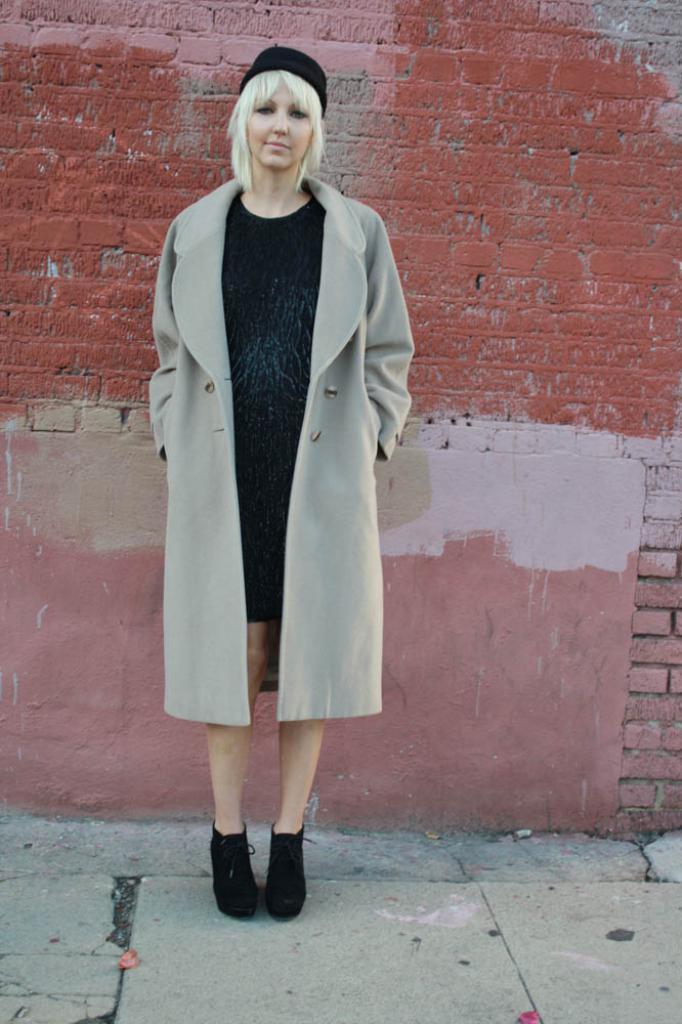Could you give a brief overview of what you see in this image? In the center of the image we can see a lady standing. She is wearing a coat. In the background there is a wall. 